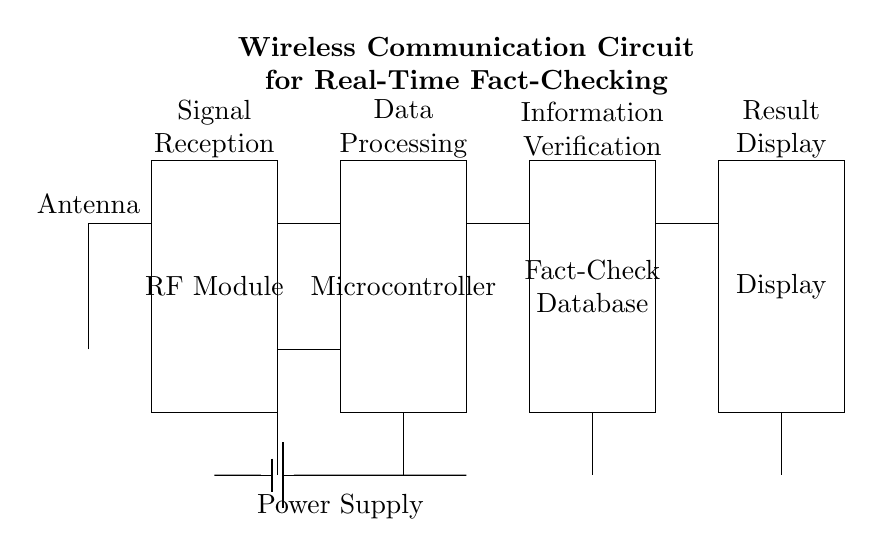What is the main function of the antenna? The antenna's main function is to receive wireless signals, which are indicated by its placement at the beginning of the circuit.
Answer: Receive wireless signals What component processes the received data? The microcontroller is responsible for processing the data after it is received by the RF module. Its position in the circuit indicates this role.
Answer: Microcontroller How many components are connected to the power supply? By tracing the connections from the power supply, we can see there are four components connected: RF Module, Microcontroller, Fact-Check Database, and Display.
Answer: Four What type of database is used in this circuit? The database is referred to as a Fact-Check Database, as shown in the labeled rectangle within the circuit, indicating its role in verifying information.
Answer: Fact-Check Database What is the output of this wireless communication circuit? The output of the circuit, as indicated by the labeled display at the end of the circuit, is the result of the information verification process.
Answer: Result Display How does the signal flow through the circuit? The signal flows from the antenna to the RF module, then to the microcontroller, moving to the Fact-Check Database and finally reaching the display stage, indicated by the directional connections.
Answer: Antenna to RF Module to Microcontroller to Fact-Check Database to Display 